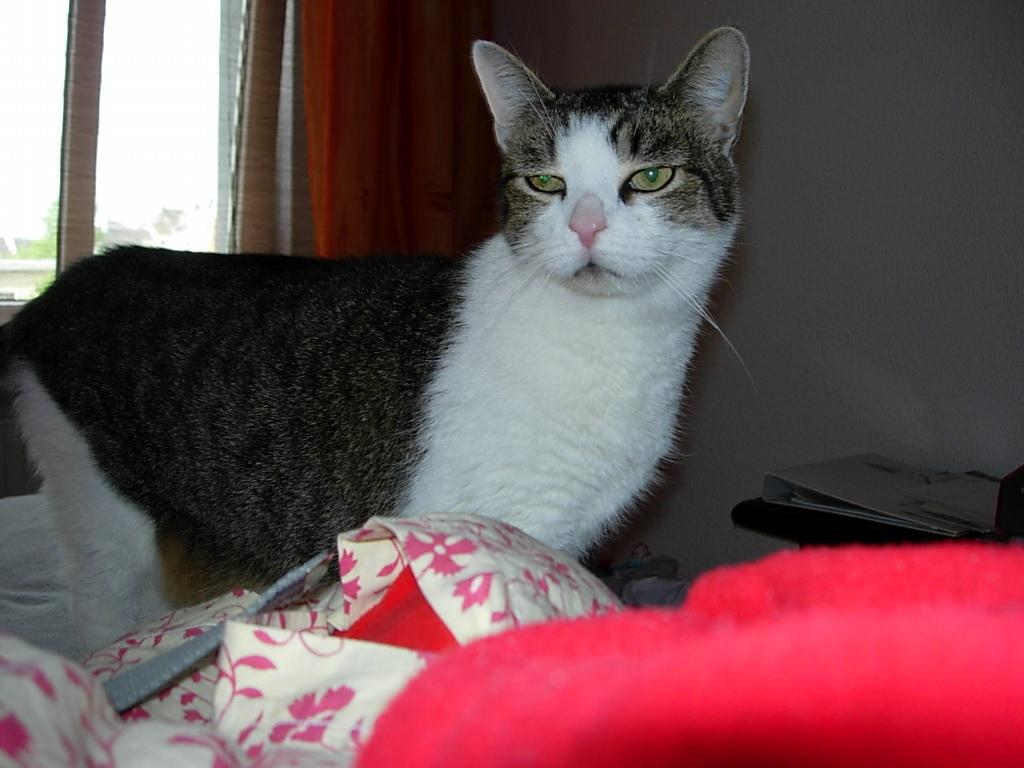What animal can be seen on the bed in the image? There is a cat on the bed. What object is located on the right side of the image? There is a table on the right side of the image. What item is on the table? A file is present on the table. Where is the window in the image? There is a window in the top left of the image. Can you see the cat attempting to jump through the window in the image? There is no indication in the image that the cat is attempting to jump through the window. 